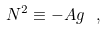Convert formula to latex. <formula><loc_0><loc_0><loc_500><loc_500>N ^ { 2 } \equiv - A g \ ,</formula> 